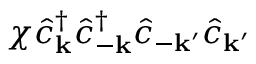<formula> <loc_0><loc_0><loc_500><loc_500>\chi \hat { c } _ { k } ^ { \dagger } \hat { c } _ { - k } ^ { \dagger } \hat { c } _ { - k ^ { \prime } } \hat { c } _ { k ^ { \prime } }</formula> 